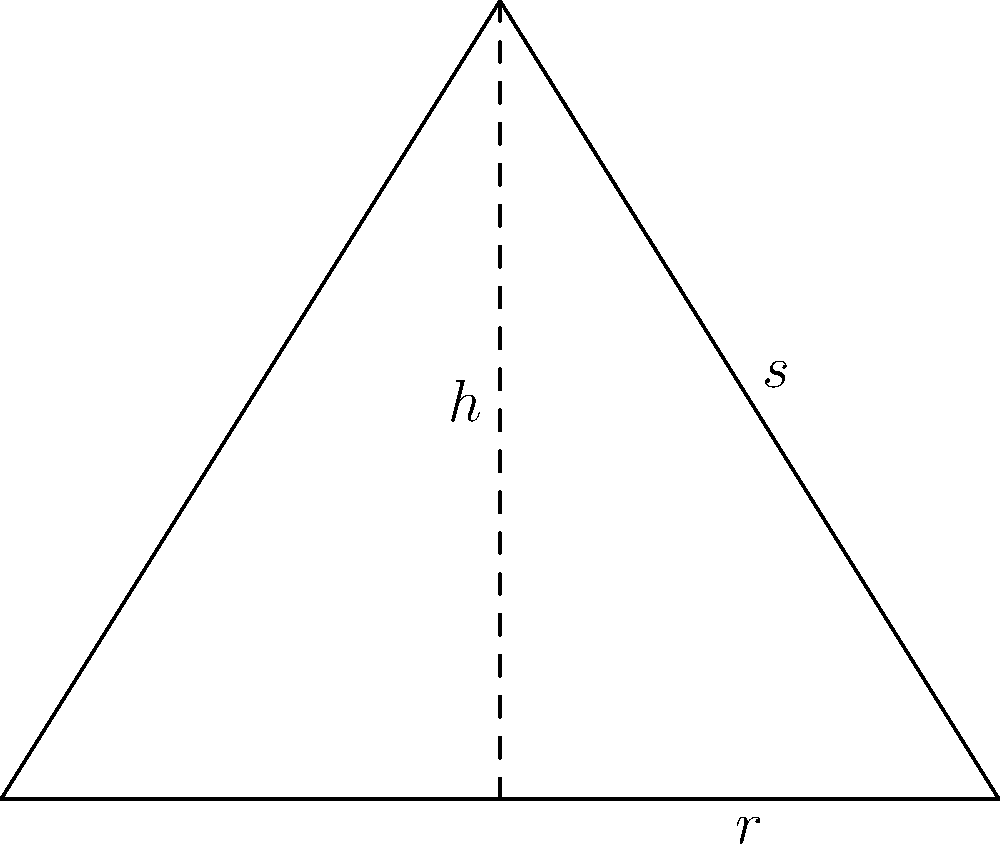An ancient burial mound has been discovered in the shape of a cone. The archaeologists have measured the slant height ($s$) of the mound to be 10 meters and the radius ($r$) of the base to be 6 meters. Calculate the surface area of the burial mound, excluding the base. Round your answer to the nearest square meter. To calculate the surface area of a conical burial mound (excluding the base), we need to use the formula for the lateral surface area of a cone:

$$A = \pi rs$$

Where:
$A$ = lateral surface area
$r$ = radius of the base
$s$ = slant height

Given:
$r = 6$ meters
$s = 10$ meters

Step 1: Substitute the values into the formula:
$$A = \pi \cdot 6 \cdot 10$$

Step 2: Calculate:
$$A = 60\pi$$

Step 3: Evaluate and round to the nearest square meter:
$$A \approx 188.5 \text{ m}^2 \approx 189 \text{ m}^2$$

The surface area of the conical burial mound, excluding the base, is approximately 189 square meters.
Answer: 189 m² 